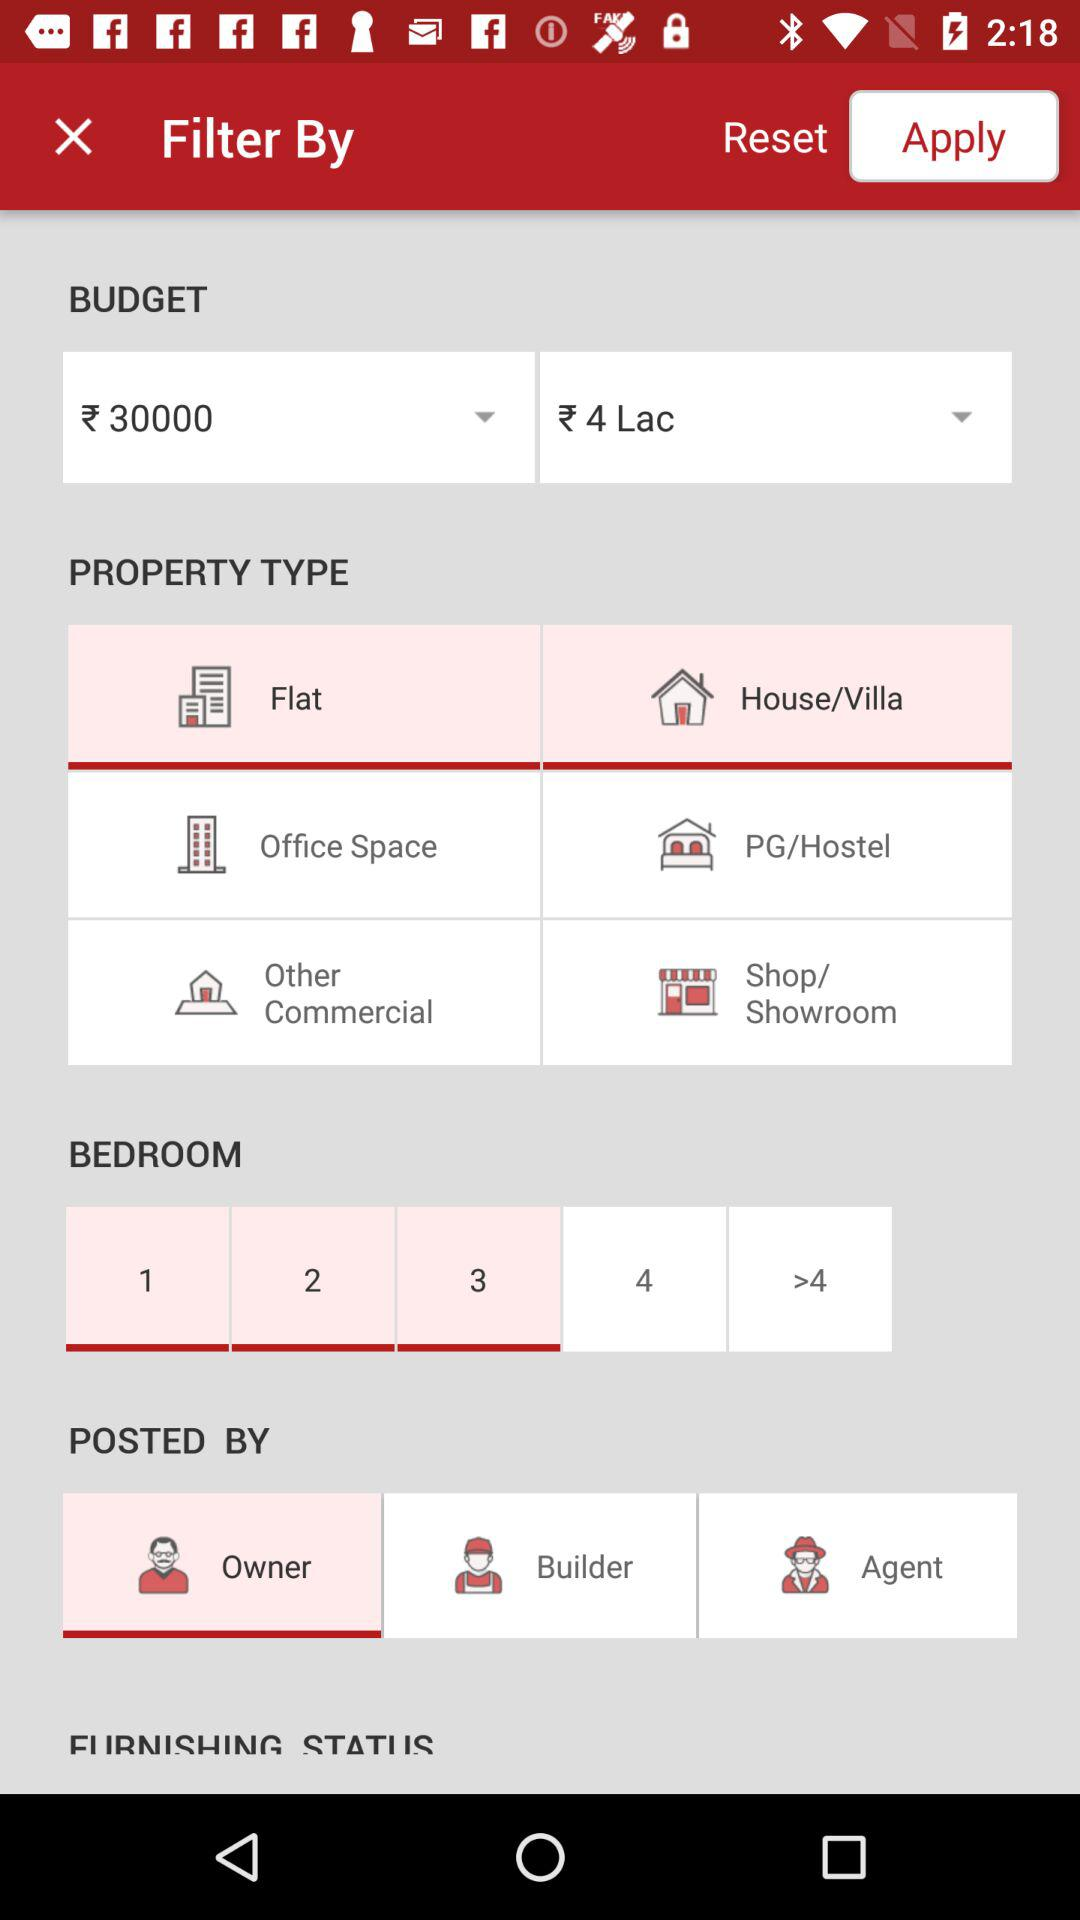Which is the property's budget range? The property's budget range is between ₹3000 to ₹4 Lac. 